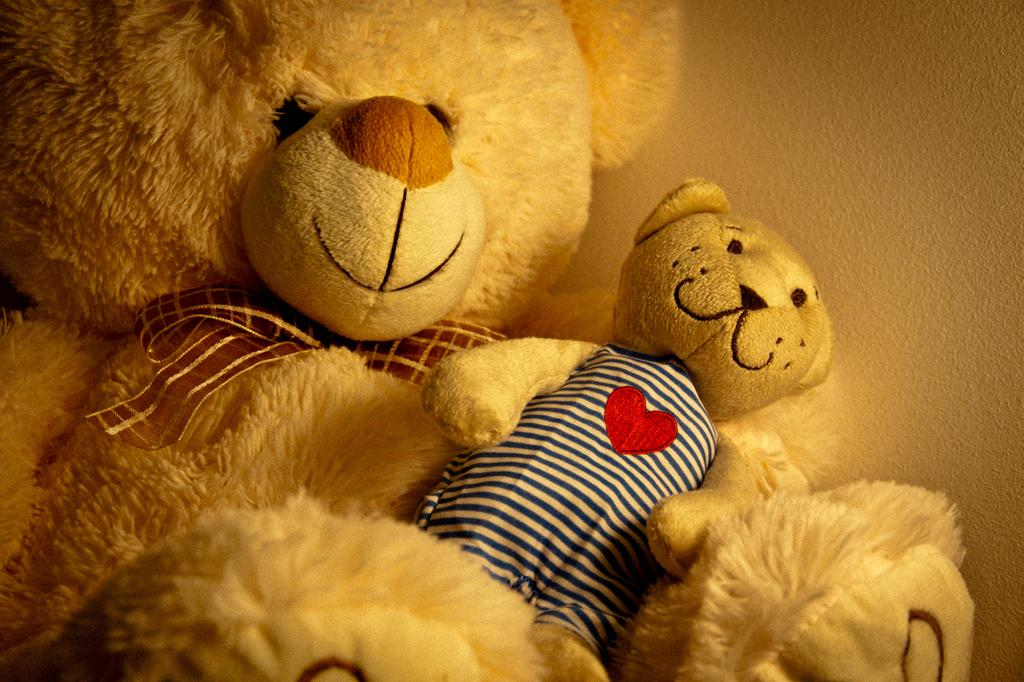How many teddy bears are in the image? There are two teddy bears in the image. Can you describe the teddy bears in terms of their size? The teddy bears are of different sizes. What else can be seen in the image besides the teddy bears? There is a wall visible in the image. What type of mint is growing on the wall in the image? There is no mint visible in the image; only the teddy bears and the wall are present. 